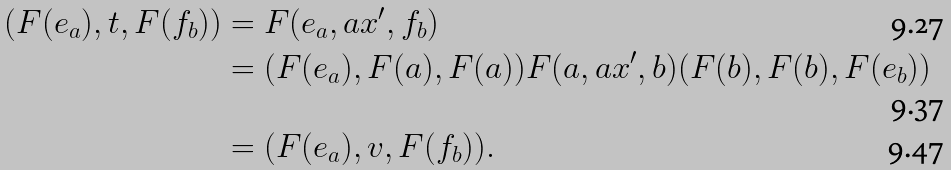<formula> <loc_0><loc_0><loc_500><loc_500>( F ( e _ { a } ) , t , F ( f _ { b } ) ) & = F ( e _ { a } , a x ^ { \prime } , f _ { b } ) \\ & = ( F ( e _ { a } ) , F ( a ) , F ( a ) ) F ( a , a x ^ { \prime } , b ) ( F ( b ) , F ( b ) , F ( e _ { b } ) ) \\ & = ( F ( e _ { a } ) , v , F ( f _ { b } ) ) .</formula> 